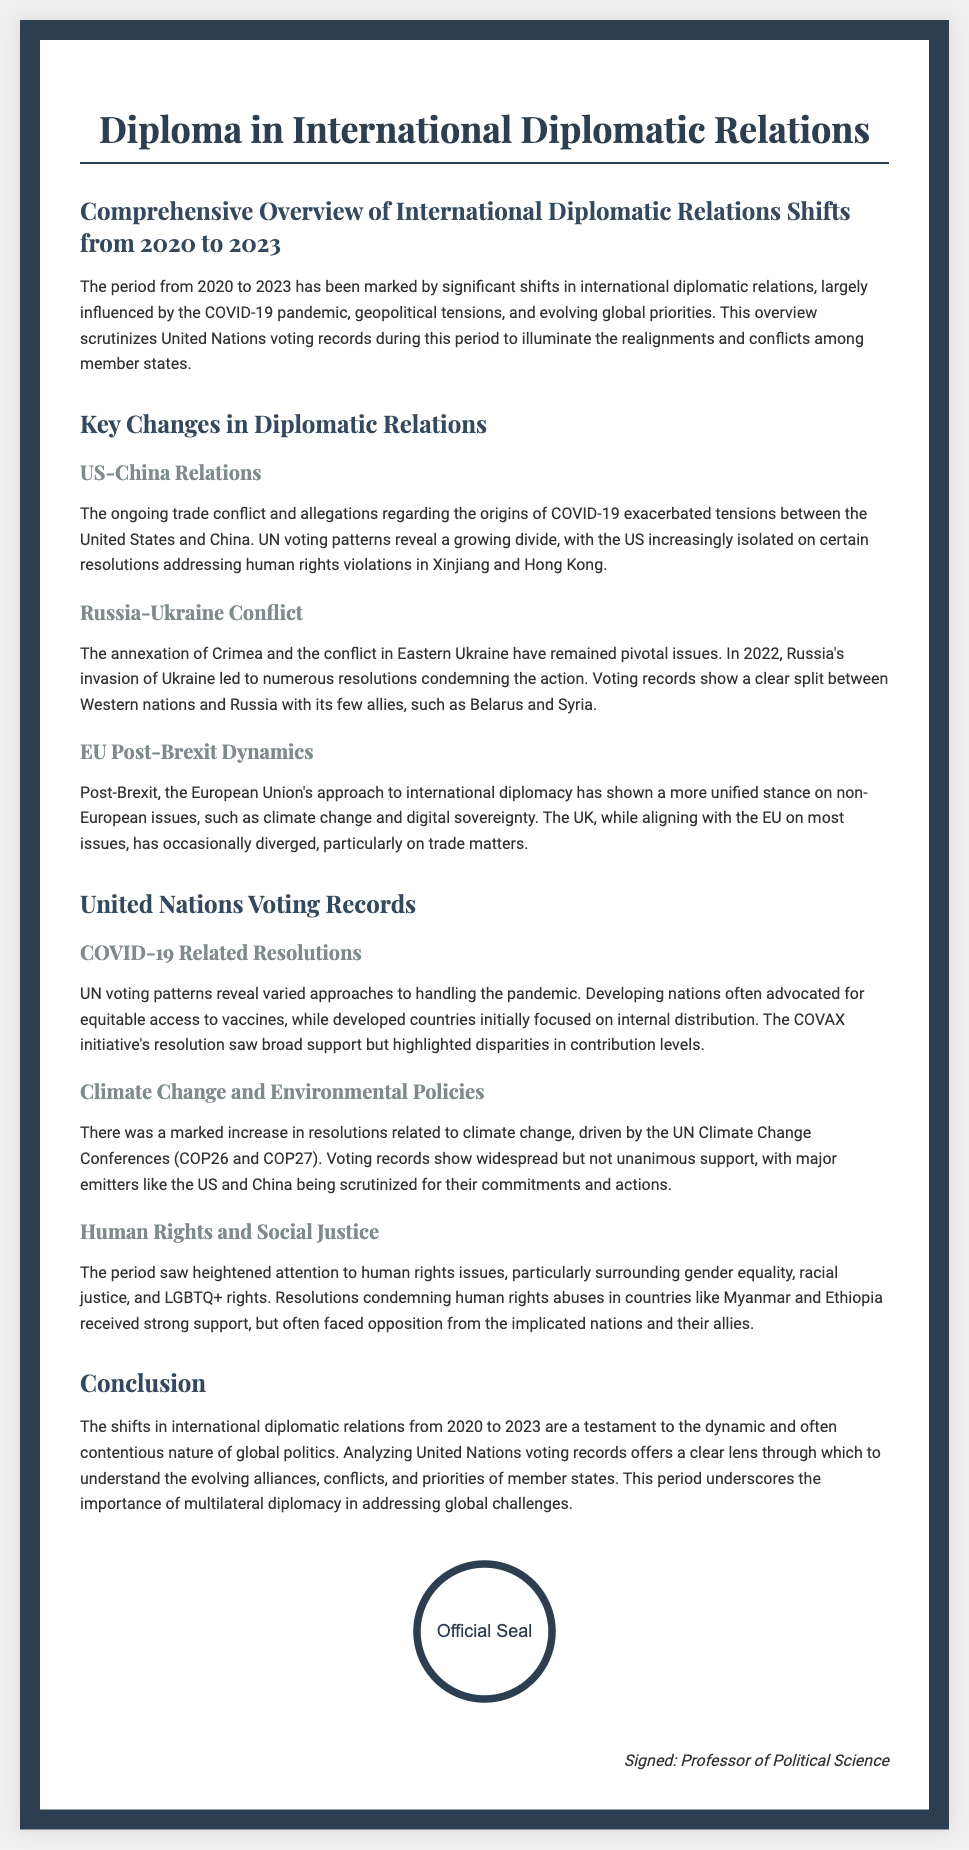What is the title of the diploma? The title is stated prominently at the top of the document under the heading.
Answer: Diploma in International Diplomatic Relations What years are focused on in the overview? The document mentions a specific time frame for the shifts in relations, highlighted in the introduction.
Answer: 2020 to 2023 Which two countries are highlighted regarding their diplomatic relations? The document explicitly discusses two countries where tensions have significantly affected international relations.
Answer: US and China What key international conflict is mentioned in relation to Russia? This conflict is pivotal in understanding the dynamics mentioned in the document and has been clearly associated with actions by Russia.
Answer: Ukraine What significant global issue has seen increased resolutions from the UN? This issue has been emphasized throughout the document as a major concern leading to various resolutions during the specified years.
Answer: Climate change Which initiative received broad support according to the voting records? The document indicates a specific initiative related to vaccine access which garnered support from various nations.
Answer: COVAX initiative What type of issues received heightened attention from 2020 to 2023? The document outlines specific rights issues that have been increasingly scrutinized during this period.
Answer: Human rights What does the document suggest about the EU's stance post-Brexit? The document explains changes in the EU's diplomatic approach following a significant political shift.
Answer: More unified stance Who signed the diploma? The signature portion of the document attributes authorship to a person with a specific role mentioned at the end.
Answer: Professor of Political Science 